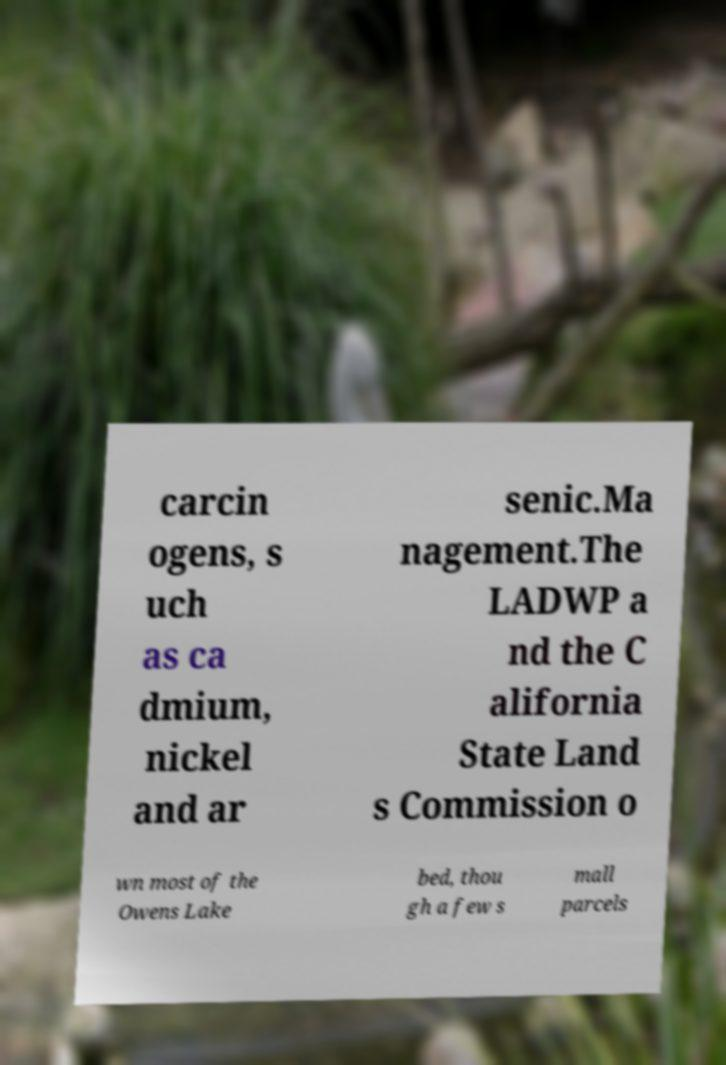Can you accurately transcribe the text from the provided image for me? carcin ogens, s uch as ca dmium, nickel and ar senic.Ma nagement.The LADWP a nd the C alifornia State Land s Commission o wn most of the Owens Lake bed, thou gh a few s mall parcels 